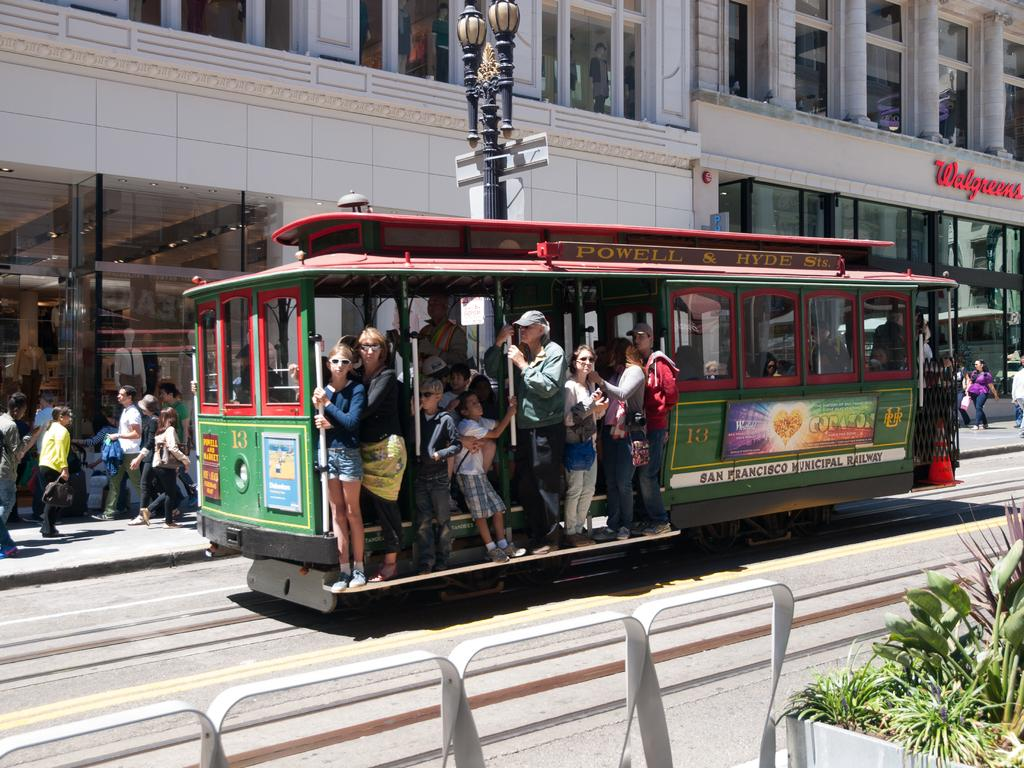<image>
Provide a brief description of the given image. Trolley that says Powell & Hyde, San Francisco Municipal Railway. 